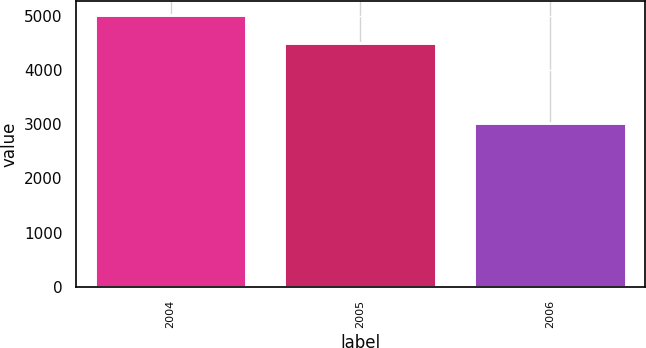Convert chart. <chart><loc_0><loc_0><loc_500><loc_500><bar_chart><fcel>2004<fcel>2005<fcel>2006<nl><fcel>5021<fcel>4496<fcel>3017<nl></chart> 